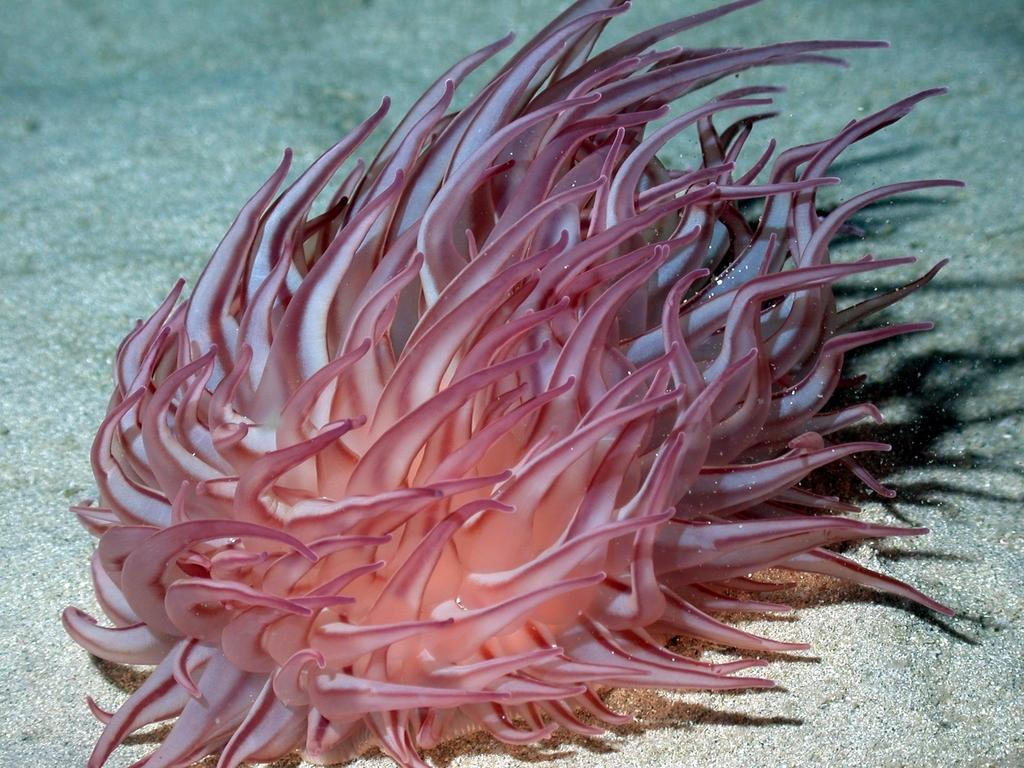What type of living organism can be seen in the image? There is an aquatic living organism in the image. How does the aquatic living organism kick in the image? The aquatic living organism does not kick in the image, as it is not a human or animal capable of kicking. 